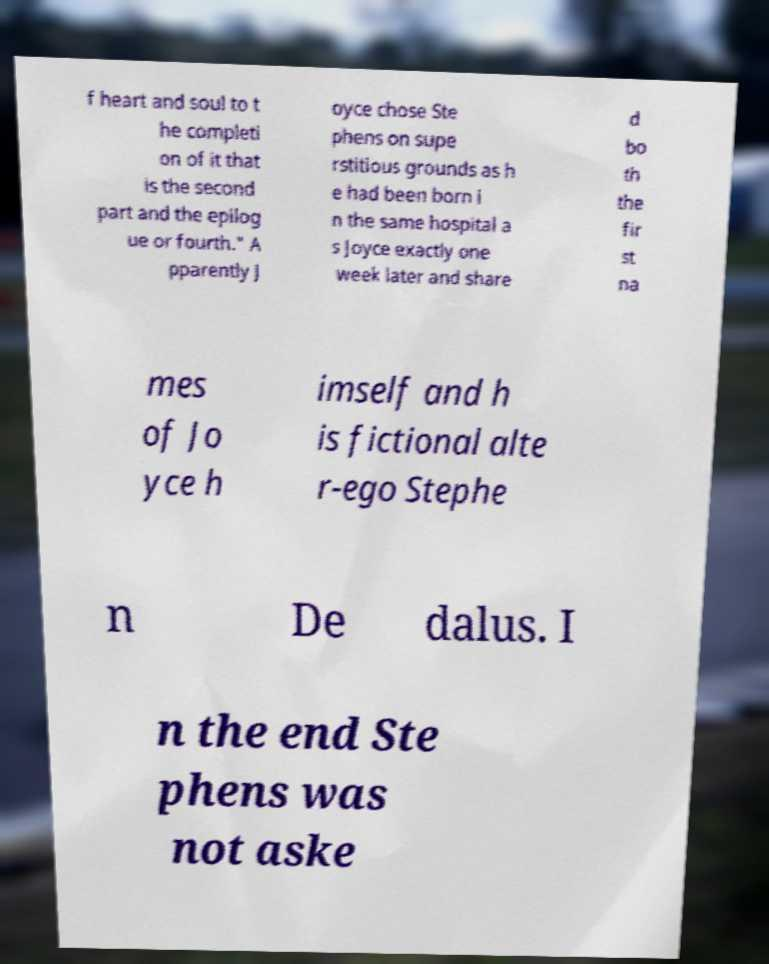Could you extract and type out the text from this image? f heart and soul to t he completi on of it that is the second part and the epilog ue or fourth." A pparently J oyce chose Ste phens on supe rstitious grounds as h e had been born i n the same hospital a s Joyce exactly one week later and share d bo th the fir st na mes of Jo yce h imself and h is fictional alte r-ego Stephe n De dalus. I n the end Ste phens was not aske 